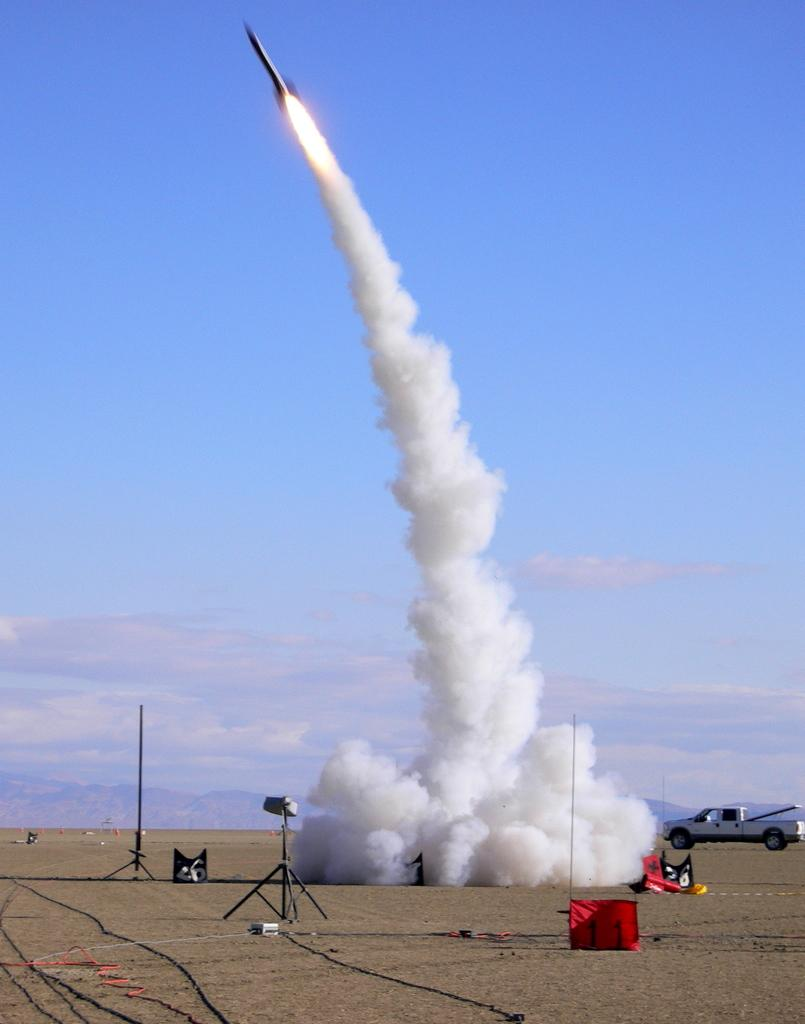What type of vehicle is in the image? There is a vehicle in the image, but the specific type is not mentioned. What else can be seen in the image besides the vehicle? There are stands and a rocket in the image. What is the rocket doing in the image? The rocket is flying in the image. What type of landscape is visible in the image? There are mountains visible in the image. What is the result of the rocket's flight in the image? There is smoke in the image as a result of the rocket's flight. Can you tell me how many toothbrushes are visible in the image? There is no toothbrush present in the image. What type of cough is depicted in the image? There is no cough depicted in the image. 